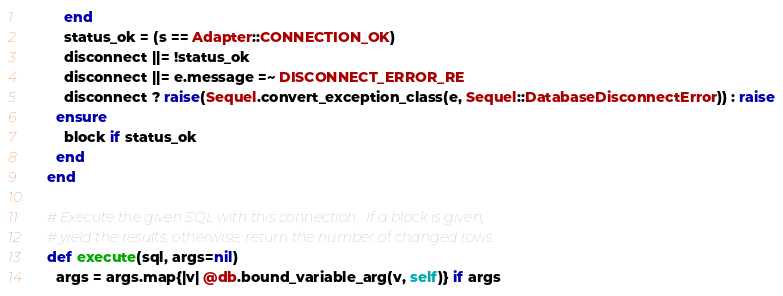<code> <loc_0><loc_0><loc_500><loc_500><_Ruby_>          end
          status_ok = (s == Adapter::CONNECTION_OK)
          disconnect ||= !status_ok
          disconnect ||= e.message =~ DISCONNECT_ERROR_RE
          disconnect ? raise(Sequel.convert_exception_class(e, Sequel::DatabaseDisconnectError)) : raise
        ensure
          block if status_ok
        end
      end

      # Execute the given SQL with this connection.  If a block is given,
      # yield the results, otherwise, return the number of changed rows.
      def execute(sql, args=nil)
        args = args.map{|v| @db.bound_variable_arg(v, self)} if args</code> 